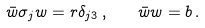<formula> <loc_0><loc_0><loc_500><loc_500>\bar { w } \sigma _ { j } w = r \delta _ { j 3 } \, , \quad \bar { w } w = b \, .</formula> 